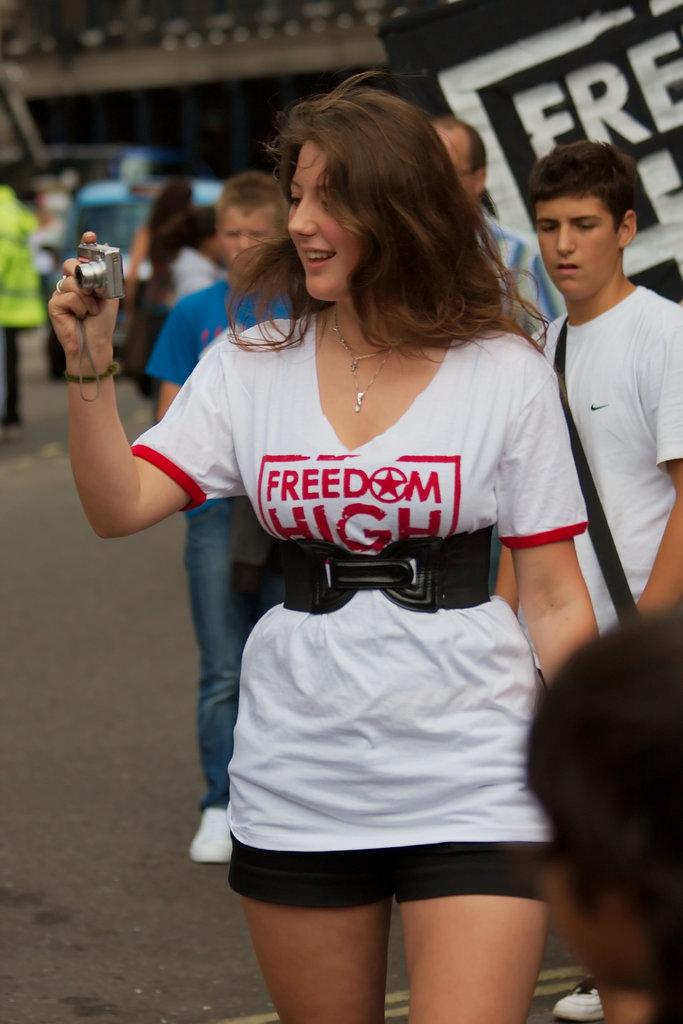What is the tea shirt plan?
Offer a very short reply. Freedom high. 